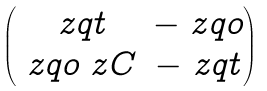Convert formula to latex. <formula><loc_0><loc_0><loc_500><loc_500>\begin{pmatrix} \ z q t & - \ z q o \\ \ z q o \ z C & - \ z q t \end{pmatrix}</formula> 